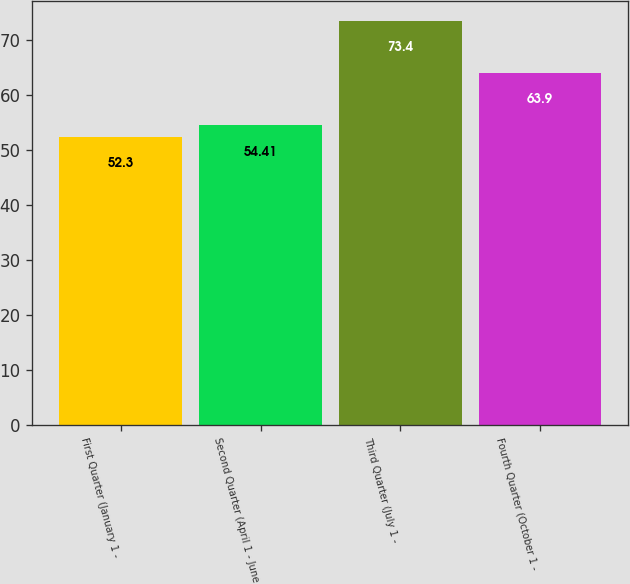Convert chart. <chart><loc_0><loc_0><loc_500><loc_500><bar_chart><fcel>First Quarter (January 1 -<fcel>Second Quarter (April 1 - June<fcel>Third Quarter (July 1 -<fcel>Fourth Quarter (October 1 -<nl><fcel>52.3<fcel>54.41<fcel>73.4<fcel>63.9<nl></chart> 